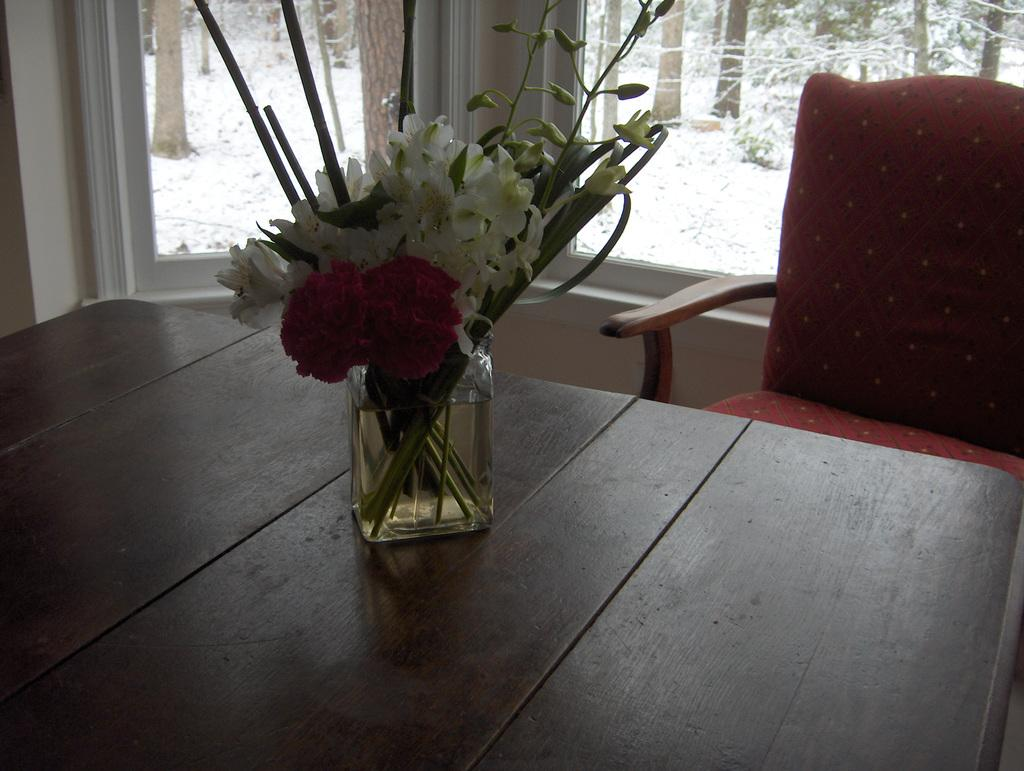What is on the table in the image? There is a flower vase on the table. What piece of furniture is located beside the table? There is a chair beside the table. What can be seen through the window in the room? Trees are visible through the window. How many lizards are crawling on the chair in the image? There are no lizards present in the image. What type of bottle is sitting on the table next to the flower vase? There is no bottle present on the table in the image. 